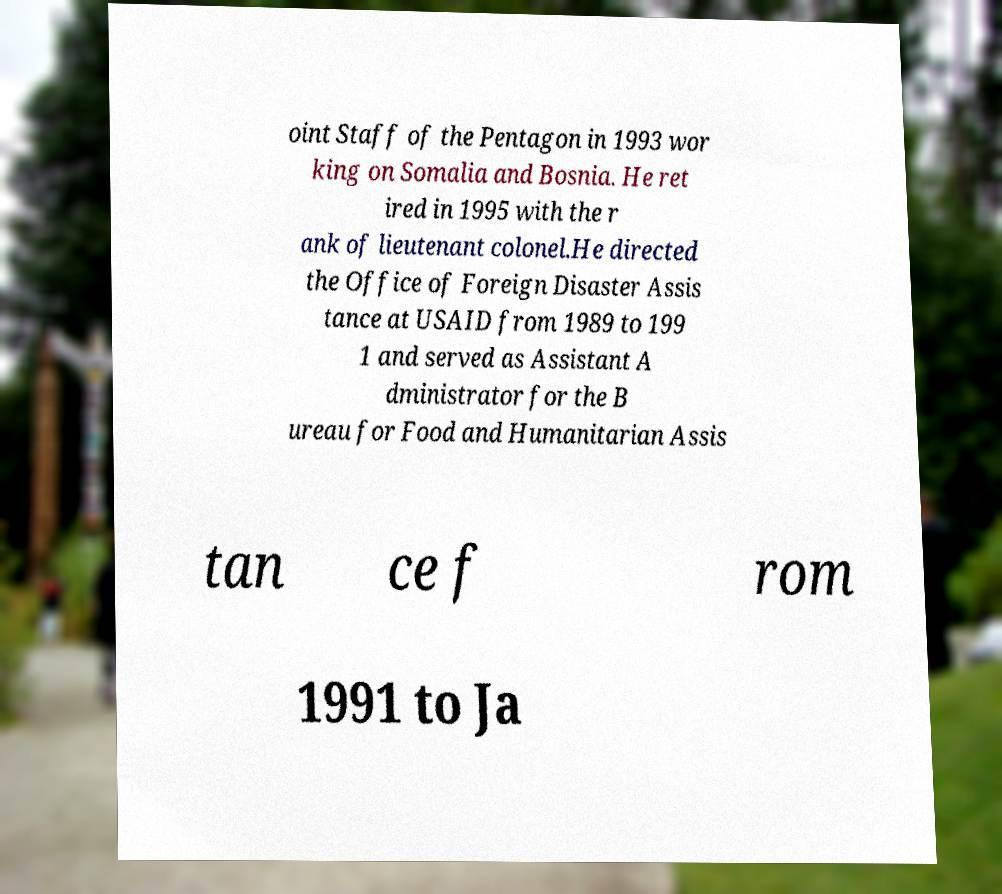For documentation purposes, I need the text within this image transcribed. Could you provide that? oint Staff of the Pentagon in 1993 wor king on Somalia and Bosnia. He ret ired in 1995 with the r ank of lieutenant colonel.He directed the Office of Foreign Disaster Assis tance at USAID from 1989 to 199 1 and served as Assistant A dministrator for the B ureau for Food and Humanitarian Assis tan ce f rom 1991 to Ja 